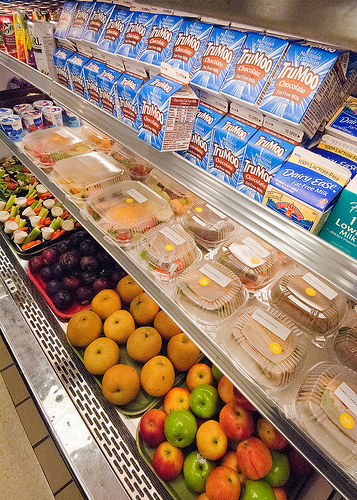<image>
Is the yogurt in front of the fruit? No. The yogurt is not in front of the fruit. The spatial positioning shows a different relationship between these objects. Is the yellow apple above the green apple? No. The yellow apple is not positioned above the green apple. The vertical arrangement shows a different relationship. 